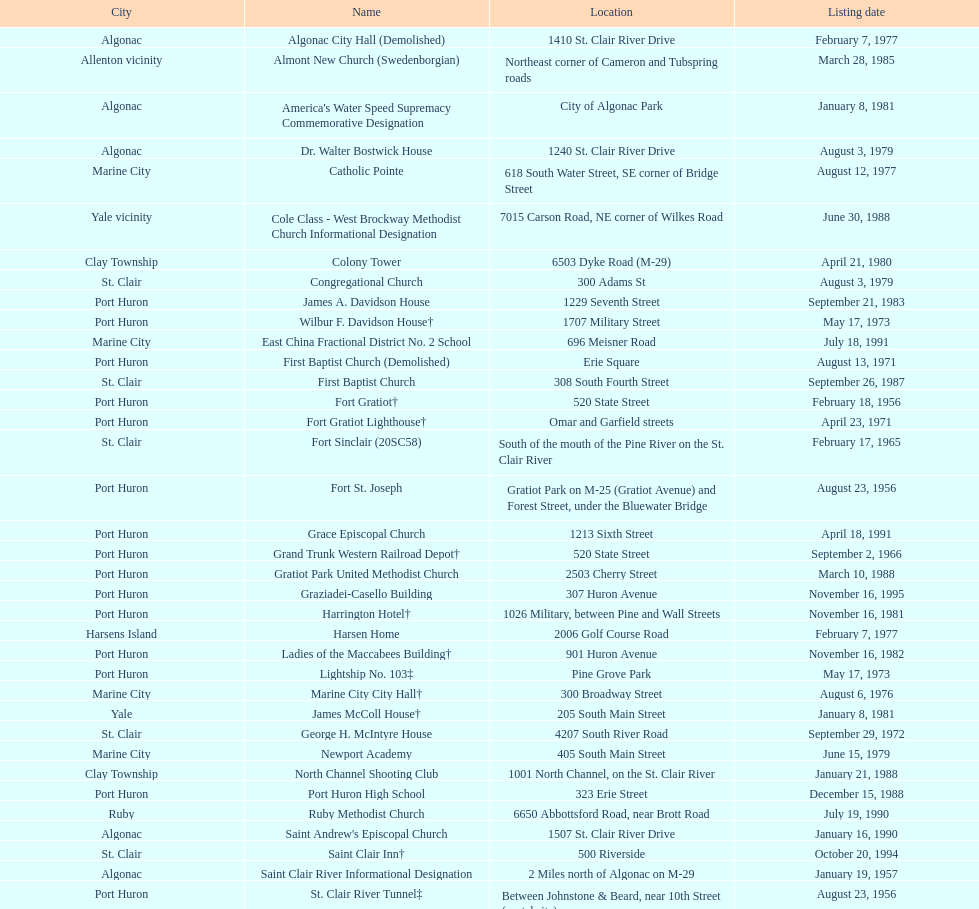How many names do not have images next to them? 41. 